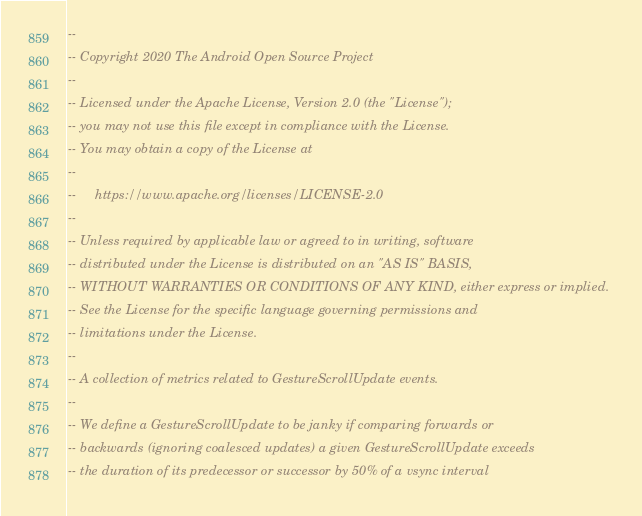Convert code to text. <code><loc_0><loc_0><loc_500><loc_500><_SQL_>--
-- Copyright 2020 The Android Open Source Project
--
-- Licensed under the Apache License, Version 2.0 (the "License");
-- you may not use this file except in compliance with the License.
-- You may obtain a copy of the License at
--
--     https://www.apache.org/licenses/LICENSE-2.0
--
-- Unless required by applicable law or agreed to in writing, software
-- distributed under the License is distributed on an "AS IS" BASIS,
-- WITHOUT WARRANTIES OR CONDITIONS OF ANY KIND, either express or implied.
-- See the License for the specific language governing permissions and
-- limitations under the License.
--
-- A collection of metrics related to GestureScrollUpdate events.
--
-- We define a GestureScrollUpdate to be janky if comparing forwards or
-- backwards (ignoring coalesced updates) a given GestureScrollUpdate exceeds
-- the duration of its predecessor or successor by 50% of a vsync interval</code> 